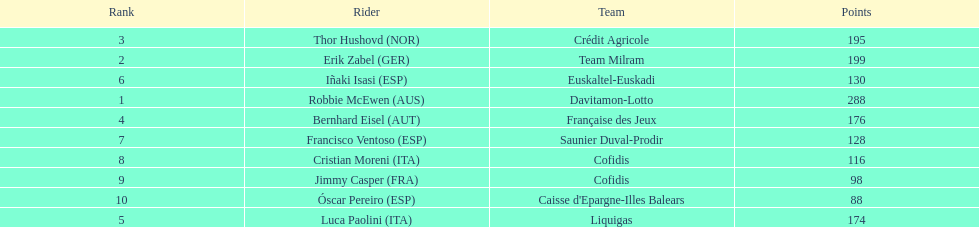How many more points did erik zabel score than franciso ventoso? 71. 